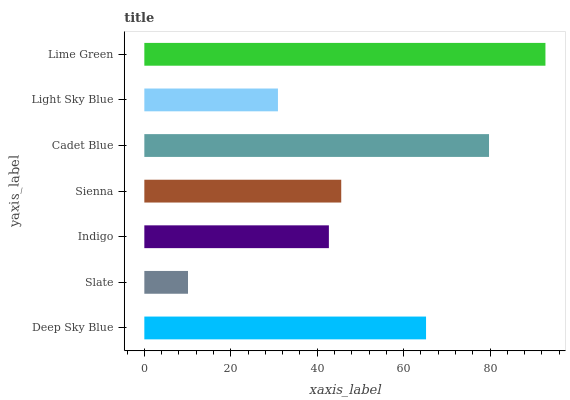Is Slate the minimum?
Answer yes or no. Yes. Is Lime Green the maximum?
Answer yes or no. Yes. Is Indigo the minimum?
Answer yes or no. No. Is Indigo the maximum?
Answer yes or no. No. Is Indigo greater than Slate?
Answer yes or no. Yes. Is Slate less than Indigo?
Answer yes or no. Yes. Is Slate greater than Indigo?
Answer yes or no. No. Is Indigo less than Slate?
Answer yes or no. No. Is Sienna the high median?
Answer yes or no. Yes. Is Sienna the low median?
Answer yes or no. Yes. Is Slate the high median?
Answer yes or no. No. Is Lime Green the low median?
Answer yes or no. No. 